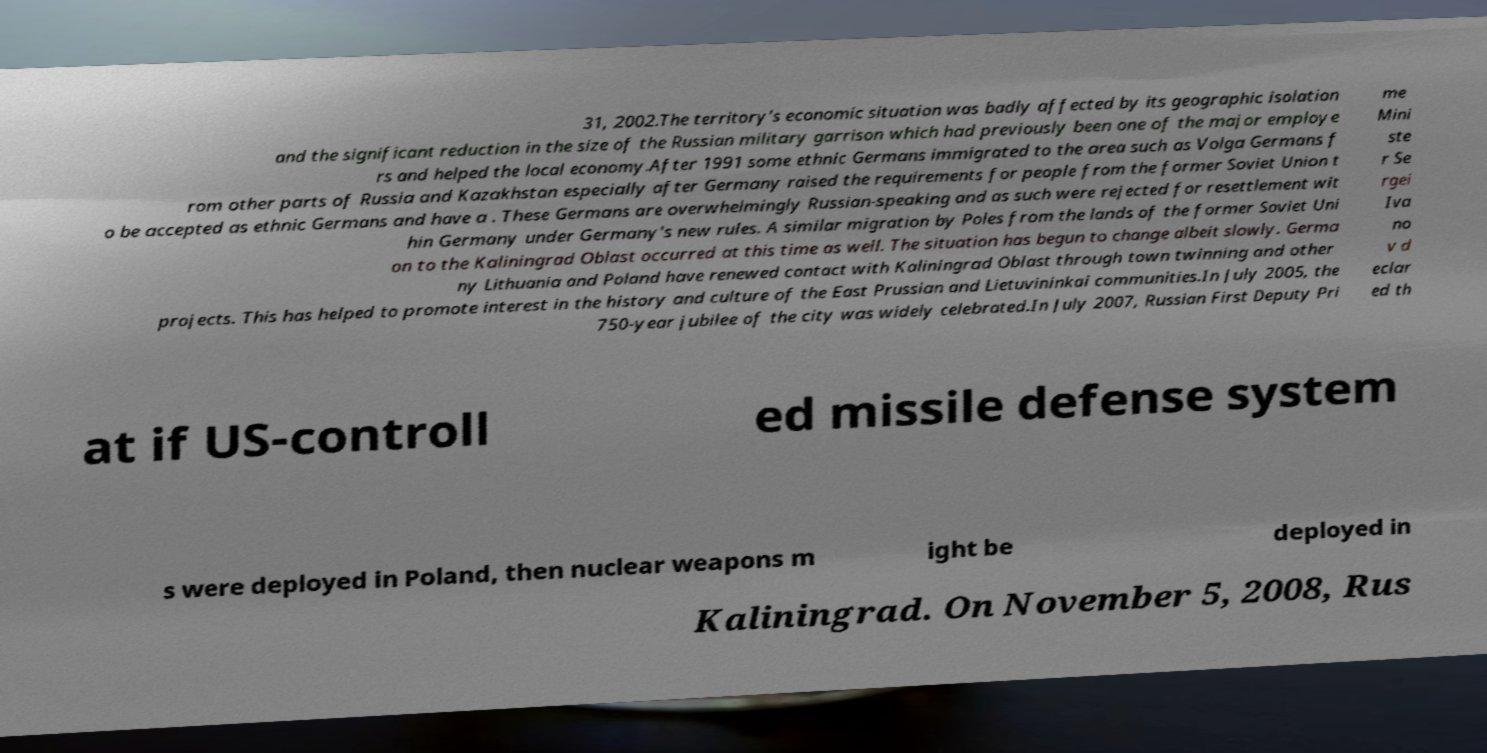There's text embedded in this image that I need extracted. Can you transcribe it verbatim? 31, 2002.The territory's economic situation was badly affected by its geographic isolation and the significant reduction in the size of the Russian military garrison which had previously been one of the major employe rs and helped the local economy.After 1991 some ethnic Germans immigrated to the area such as Volga Germans f rom other parts of Russia and Kazakhstan especially after Germany raised the requirements for people from the former Soviet Union t o be accepted as ethnic Germans and have a . These Germans are overwhelmingly Russian-speaking and as such were rejected for resettlement wit hin Germany under Germany's new rules. A similar migration by Poles from the lands of the former Soviet Uni on to the Kaliningrad Oblast occurred at this time as well. The situation has begun to change albeit slowly. Germa ny Lithuania and Poland have renewed contact with Kaliningrad Oblast through town twinning and other projects. This has helped to promote interest in the history and culture of the East Prussian and Lietuvininkai communities.In July 2005, the 750-year jubilee of the city was widely celebrated.In July 2007, Russian First Deputy Pri me Mini ste r Se rgei Iva no v d eclar ed th at if US-controll ed missile defense system s were deployed in Poland, then nuclear weapons m ight be deployed in Kaliningrad. On November 5, 2008, Rus 